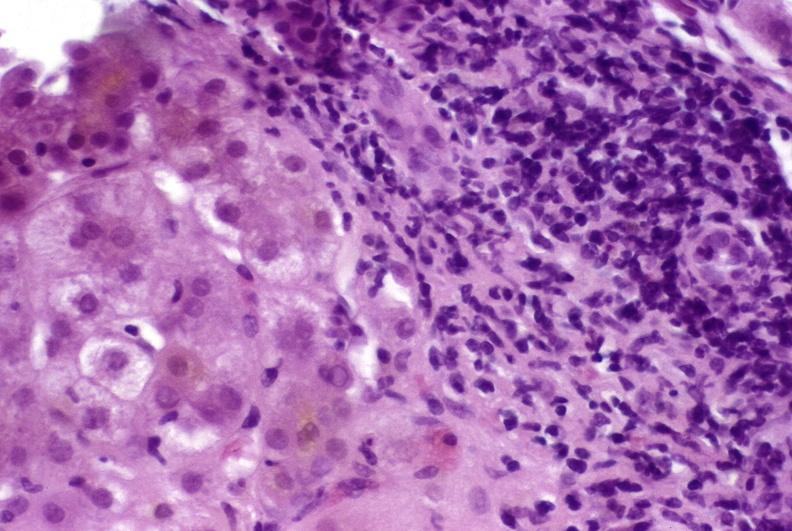what does this image show?
Answer the question using a single word or phrase. Autoimmune hepatitis 